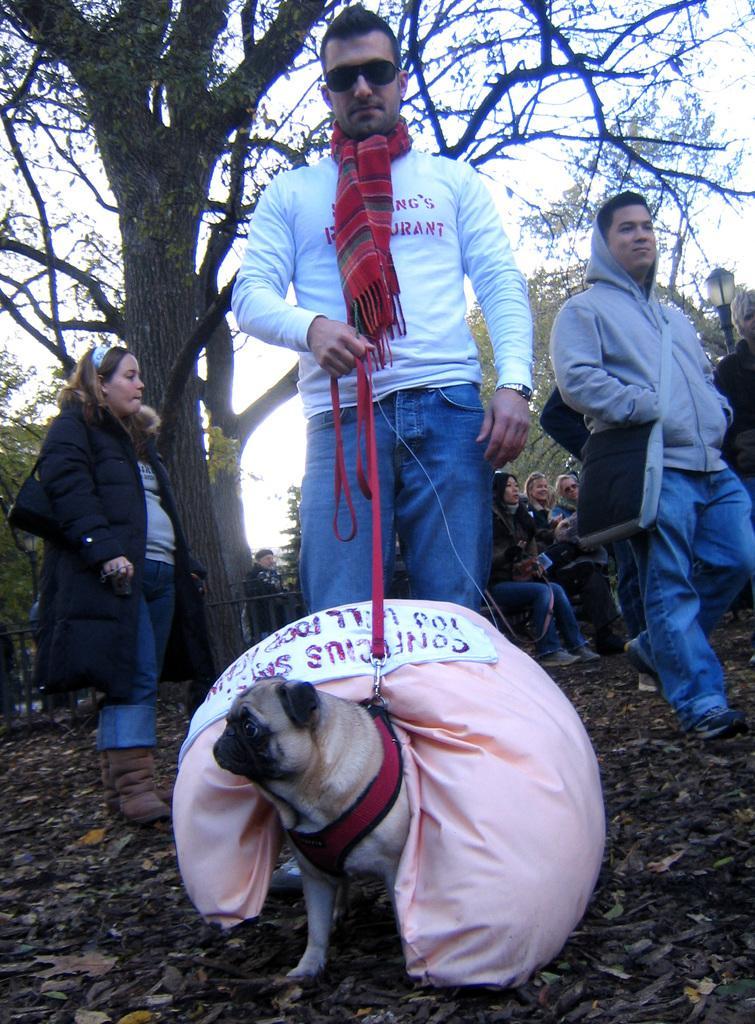In one or two sentences, can you explain what this image depicts? A man is holding belt tied to the dog. There is a bag on the dog. In the background there are few people,trees and sky. 